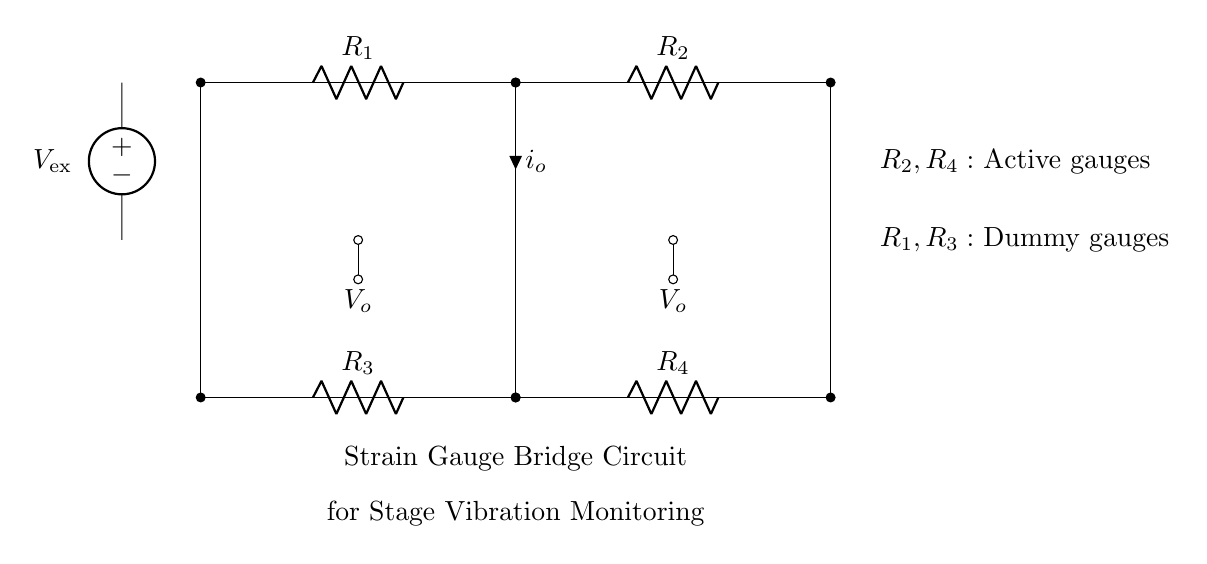What type of circuit is represented? This circuit is a strain gauge bridge circuit, which is identified by the arrangement of resistors in a bridge configuration and its application for measuring strain.
Answer: Strain gauge bridge circuit How many resistors are in the circuit? By counting the components in the diagram, there are a total of four resistors shown in the bridge circuit.
Answer: Four What is the purpose of R1 and R3? R1 and R3 are categorized as dummy gauges, which are used to balance the bridge and eliminate temperature effects on the measurement, while R2 and R4 are the active gauges.
Answer: Dummy gauges What does V_ex represent in the circuit? V_ex is the external voltage source that provides the necessary excitation voltage for the strain gauges in the bridge circuit.
Answer: Excitation voltage What is the function of the current i_o? The current i_o flowing through the circuit represents the output current, which is influenced by the resistance changes in the active strain gauges as they respond to vibrations.
Answer: Output current What is the main application of this circuit setup? This circuit setup is typically used for monitoring vibrations in concert stage structures, ensuring structural integrity and safety during performances.
Answer: Vibration monitoring How is the voltage output denoted in the circuit? The voltage output (V_o) is denoted at two points in the circuit, indicating where the differential voltage can be measured to analyze strain effects.
Answer: Voltage output 